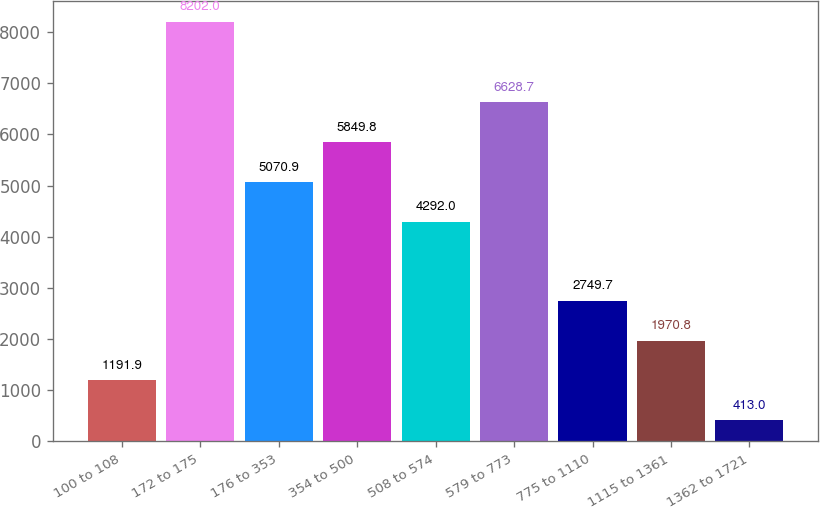<chart> <loc_0><loc_0><loc_500><loc_500><bar_chart><fcel>100 to 108<fcel>172 to 175<fcel>176 to 353<fcel>354 to 500<fcel>508 to 574<fcel>579 to 773<fcel>775 to 1110<fcel>1115 to 1361<fcel>1362 to 1721<nl><fcel>1191.9<fcel>8202<fcel>5070.9<fcel>5849.8<fcel>4292<fcel>6628.7<fcel>2749.7<fcel>1970.8<fcel>413<nl></chart> 